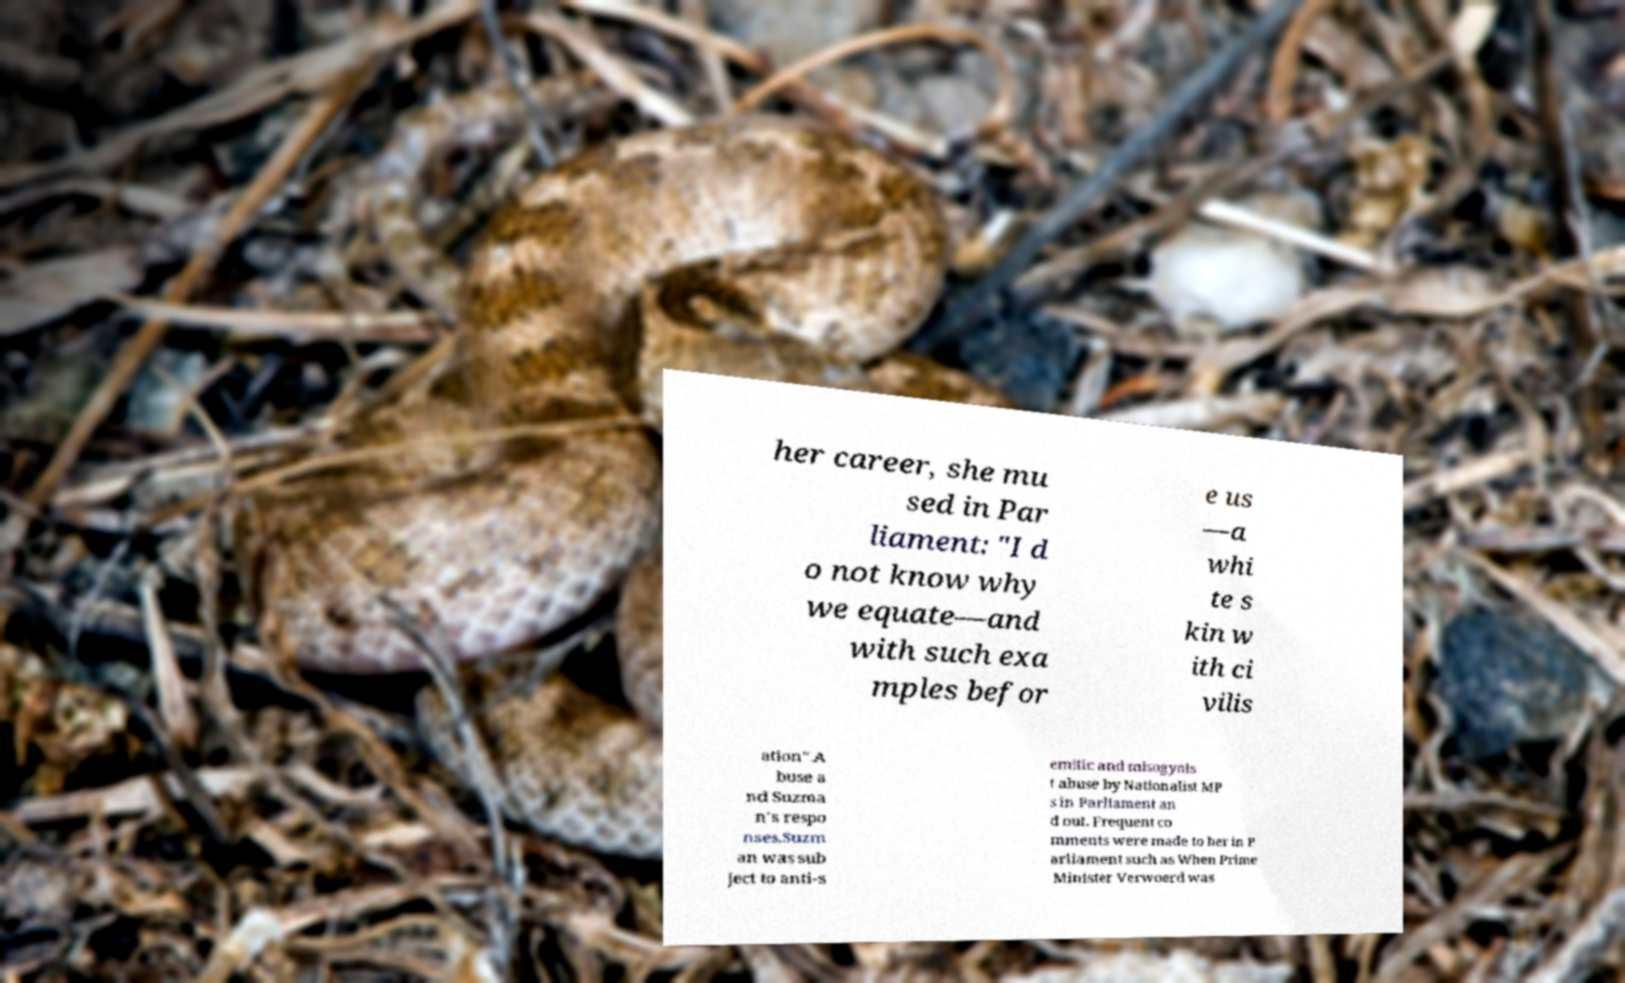Please identify and transcribe the text found in this image. her career, she mu sed in Par liament: "I d o not know why we equate—and with such exa mples befor e us —a whi te s kin w ith ci vilis ation".A buse a nd Suzma n's respo nses.Suzm an was sub ject to anti-s emitic and misogynis t abuse by Nationalist MP s in Parliament an d out. Frequent co mments were made to her in P arliament such as When Prime Minister Verwoerd was 